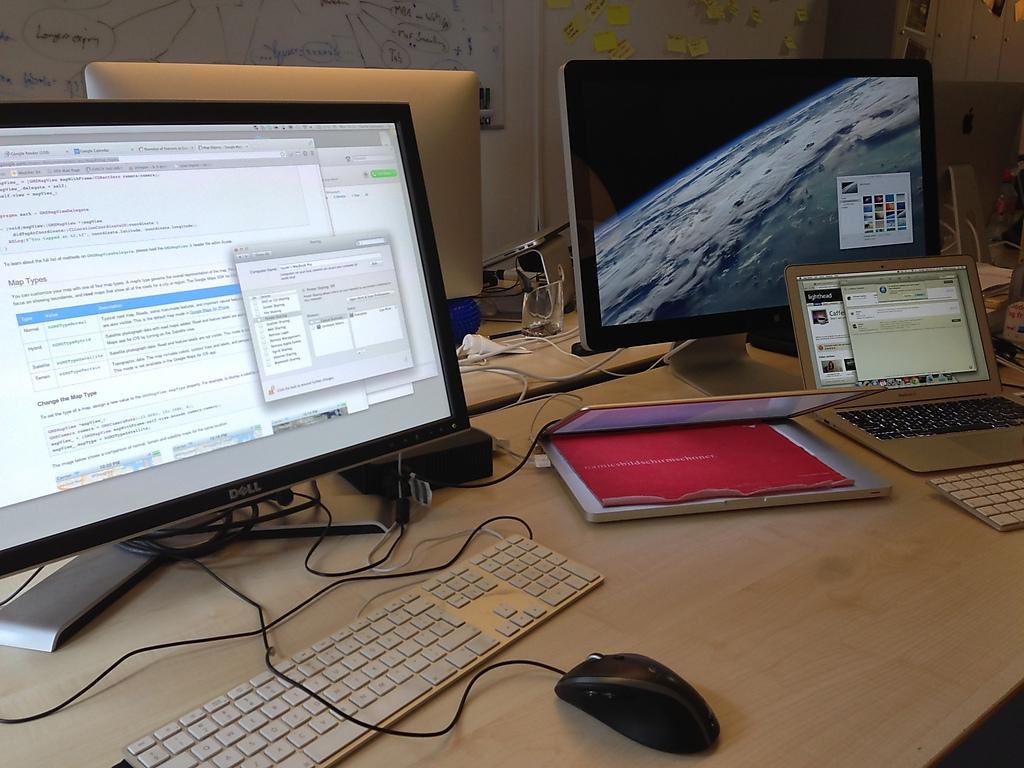<image>
Describe the image concisely. Two computers, one of which has a keyboard on which the letter C is at the bottom left 